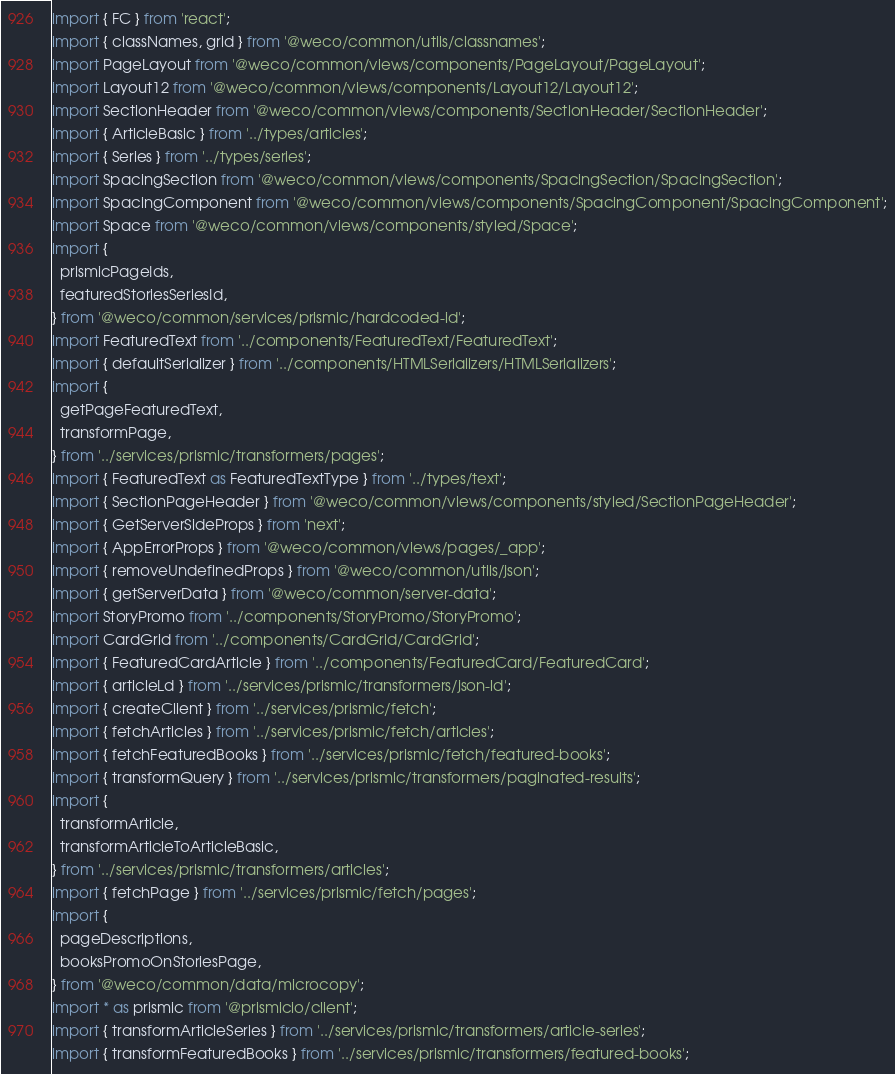<code> <loc_0><loc_0><loc_500><loc_500><_TypeScript_>import { FC } from 'react';
import { classNames, grid } from '@weco/common/utils/classnames';
import PageLayout from '@weco/common/views/components/PageLayout/PageLayout';
import Layout12 from '@weco/common/views/components/Layout12/Layout12';
import SectionHeader from '@weco/common/views/components/SectionHeader/SectionHeader';
import { ArticleBasic } from '../types/articles';
import { Series } from '../types/series';
import SpacingSection from '@weco/common/views/components/SpacingSection/SpacingSection';
import SpacingComponent from '@weco/common/views/components/SpacingComponent/SpacingComponent';
import Space from '@weco/common/views/components/styled/Space';
import {
  prismicPageIds,
  featuredStoriesSeriesId,
} from '@weco/common/services/prismic/hardcoded-id';
import FeaturedText from '../components/FeaturedText/FeaturedText';
import { defaultSerializer } from '../components/HTMLSerializers/HTMLSerializers';
import {
  getPageFeaturedText,
  transformPage,
} from '../services/prismic/transformers/pages';
import { FeaturedText as FeaturedTextType } from '../types/text';
import { SectionPageHeader } from '@weco/common/views/components/styled/SectionPageHeader';
import { GetServerSideProps } from 'next';
import { AppErrorProps } from '@weco/common/views/pages/_app';
import { removeUndefinedProps } from '@weco/common/utils/json';
import { getServerData } from '@weco/common/server-data';
import StoryPromo from '../components/StoryPromo/StoryPromo';
import CardGrid from '../components/CardGrid/CardGrid';
import { FeaturedCardArticle } from '../components/FeaturedCard/FeaturedCard';
import { articleLd } from '../services/prismic/transformers/json-ld';
import { createClient } from '../services/prismic/fetch';
import { fetchArticles } from '../services/prismic/fetch/articles';
import { fetchFeaturedBooks } from '../services/prismic/fetch/featured-books';
import { transformQuery } from '../services/prismic/transformers/paginated-results';
import {
  transformArticle,
  transformArticleToArticleBasic,
} from '../services/prismic/transformers/articles';
import { fetchPage } from '../services/prismic/fetch/pages';
import {
  pageDescriptions,
  booksPromoOnStoriesPage,
} from '@weco/common/data/microcopy';
import * as prismic from '@prismicio/client';
import { transformArticleSeries } from '../services/prismic/transformers/article-series';
import { transformFeaturedBooks } from '../services/prismic/transformers/featured-books';</code> 